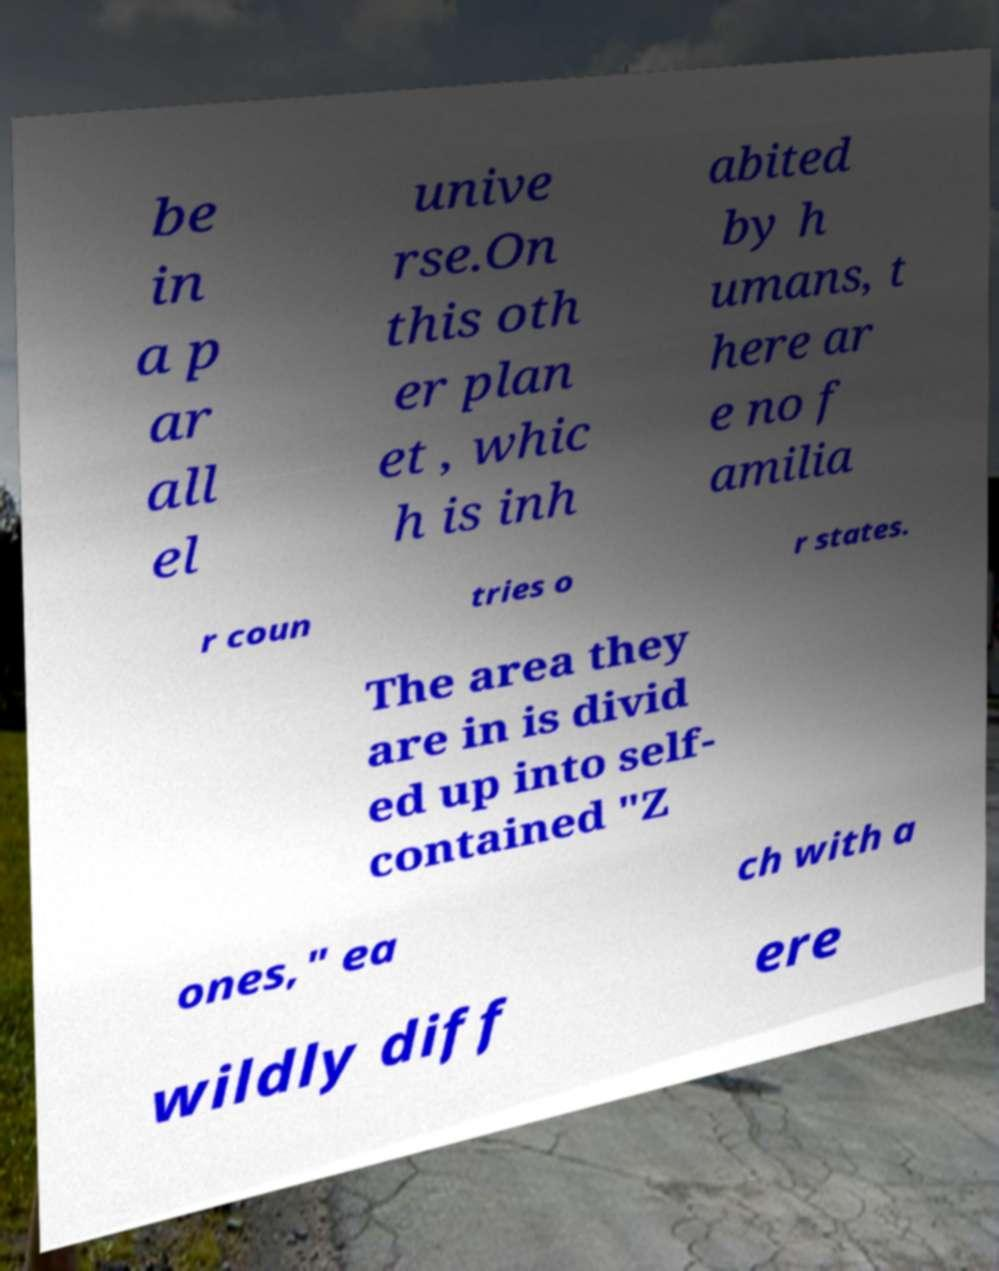What messages or text are displayed in this image? I need them in a readable, typed format. be in a p ar all el unive rse.On this oth er plan et , whic h is inh abited by h umans, t here ar e no f amilia r coun tries o r states. The area they are in is divid ed up into self- contained "Z ones," ea ch with a wildly diff ere 